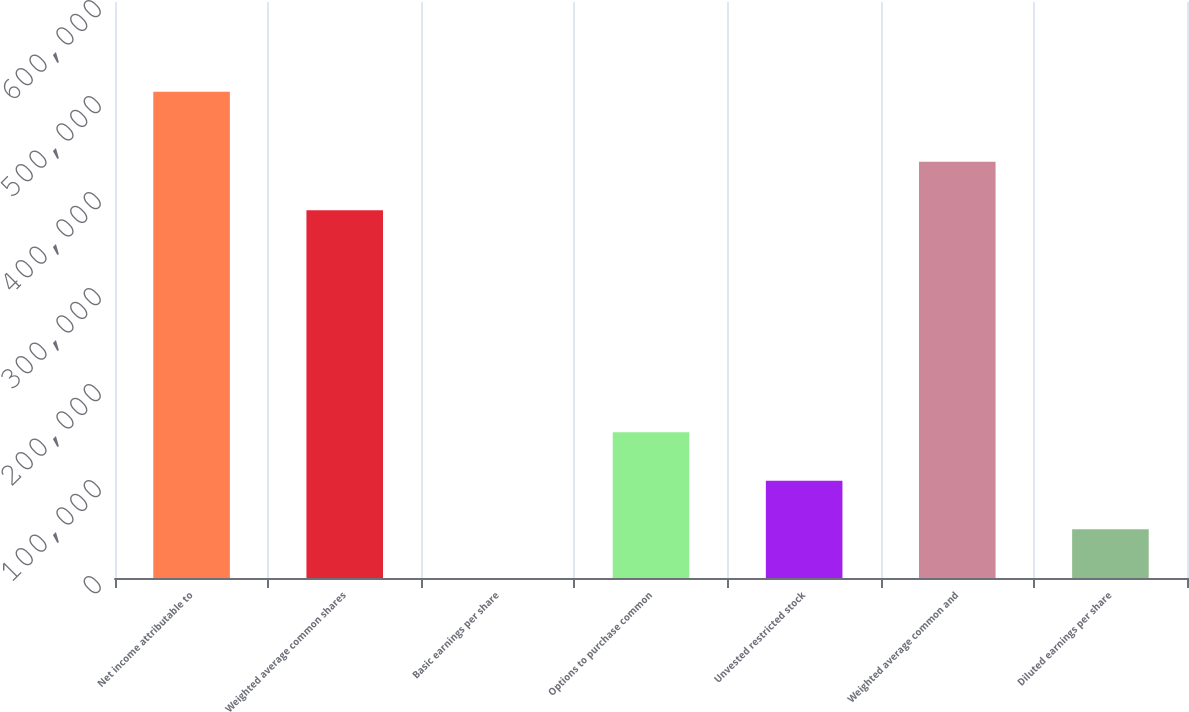<chart> <loc_0><loc_0><loc_500><loc_500><bar_chart><fcel>Net income attributable to<fcel>Weighted average common shares<fcel>Basic earnings per share<fcel>Options to purchase common<fcel>Unvested restricted stock<fcel>Weighted average common and<fcel>Diluted earnings per share<nl><fcel>506500<fcel>382985<fcel>1.32<fcel>151951<fcel>101301<fcel>433635<fcel>50651.2<nl></chart> 